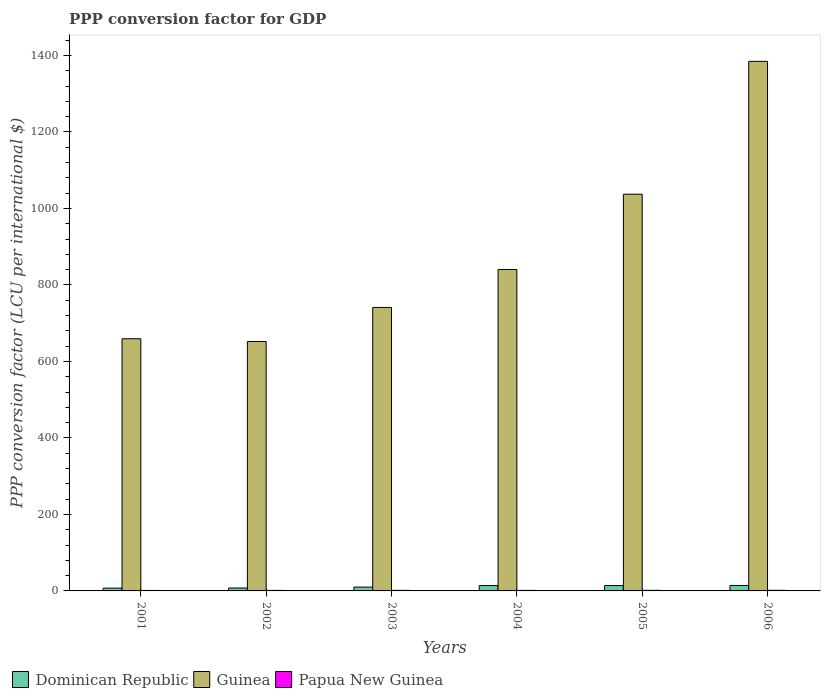How many different coloured bars are there?
Provide a succinct answer. 3. How many groups of bars are there?
Provide a succinct answer. 6. Are the number of bars per tick equal to the number of legend labels?
Your response must be concise. Yes. Are the number of bars on each tick of the X-axis equal?
Provide a short and direct response. Yes. How many bars are there on the 6th tick from the left?
Make the answer very short. 3. How many bars are there on the 5th tick from the right?
Your answer should be compact. 3. In how many cases, is the number of bars for a given year not equal to the number of legend labels?
Ensure brevity in your answer.  0. What is the PPP conversion factor for GDP in Papua New Guinea in 2001?
Provide a succinct answer. 1.29. Across all years, what is the maximum PPP conversion factor for GDP in Papua New Guinea?
Offer a terse response. 1.62. Across all years, what is the minimum PPP conversion factor for GDP in Papua New Guinea?
Offer a terse response. 1.29. What is the total PPP conversion factor for GDP in Guinea in the graph?
Offer a very short reply. 5315.08. What is the difference between the PPP conversion factor for GDP in Papua New Guinea in 2001 and that in 2003?
Your response must be concise. -0.19. What is the difference between the PPP conversion factor for GDP in Guinea in 2005 and the PPP conversion factor for GDP in Papua New Guinea in 2004?
Keep it short and to the point. 1035.92. What is the average PPP conversion factor for GDP in Papua New Guinea per year?
Ensure brevity in your answer.  1.46. In the year 2003, what is the difference between the PPP conversion factor for GDP in Guinea and PPP conversion factor for GDP in Papua New Guinea?
Offer a terse response. 739.67. In how many years, is the PPP conversion factor for GDP in Dominican Republic greater than 400 LCU?
Your response must be concise. 0. What is the ratio of the PPP conversion factor for GDP in Dominican Republic in 2002 to that in 2003?
Your answer should be very brief. 0.76. Is the PPP conversion factor for GDP in Papua New Guinea in 2003 less than that in 2006?
Provide a succinct answer. Yes. Is the difference between the PPP conversion factor for GDP in Guinea in 2002 and 2006 greater than the difference between the PPP conversion factor for GDP in Papua New Guinea in 2002 and 2006?
Offer a terse response. No. What is the difference between the highest and the second highest PPP conversion factor for GDP in Guinea?
Offer a very short reply. 347.33. What is the difference between the highest and the lowest PPP conversion factor for GDP in Papua New Guinea?
Make the answer very short. 0.33. In how many years, is the PPP conversion factor for GDP in Papua New Guinea greater than the average PPP conversion factor for GDP in Papua New Guinea taken over all years?
Keep it short and to the point. 3. What does the 3rd bar from the left in 2004 represents?
Your answer should be compact. Papua New Guinea. What does the 1st bar from the right in 2005 represents?
Provide a short and direct response. Papua New Guinea. How many bars are there?
Your answer should be very brief. 18. Are all the bars in the graph horizontal?
Provide a short and direct response. No. How many years are there in the graph?
Your answer should be very brief. 6. What is the difference between two consecutive major ticks on the Y-axis?
Your answer should be very brief. 200. Are the values on the major ticks of Y-axis written in scientific E-notation?
Offer a very short reply. No. Does the graph contain any zero values?
Make the answer very short. No. Does the graph contain grids?
Offer a very short reply. No. Where does the legend appear in the graph?
Keep it short and to the point. Bottom left. How many legend labels are there?
Ensure brevity in your answer.  3. How are the legend labels stacked?
Give a very brief answer. Horizontal. What is the title of the graph?
Keep it short and to the point. PPP conversion factor for GDP. Does "United Arab Emirates" appear as one of the legend labels in the graph?
Provide a succinct answer. No. What is the label or title of the X-axis?
Your answer should be very brief. Years. What is the label or title of the Y-axis?
Provide a succinct answer. PPP conversion factor (LCU per international $). What is the PPP conversion factor (LCU per international $) of Dominican Republic in 2001?
Give a very brief answer. 7.31. What is the PPP conversion factor (LCU per international $) of Guinea in 2001?
Keep it short and to the point. 659.32. What is the PPP conversion factor (LCU per international $) in Papua New Guinea in 2001?
Offer a very short reply. 1.29. What is the PPP conversion factor (LCU per international $) of Dominican Republic in 2002?
Your answer should be compact. 7.59. What is the PPP conversion factor (LCU per international $) in Guinea in 2002?
Ensure brevity in your answer.  652.16. What is the PPP conversion factor (LCU per international $) of Papua New Guinea in 2002?
Your response must be concise. 1.42. What is the PPP conversion factor (LCU per international $) in Dominican Republic in 2003?
Provide a short and direct response. 9.94. What is the PPP conversion factor (LCU per international $) in Guinea in 2003?
Give a very brief answer. 741.15. What is the PPP conversion factor (LCU per international $) in Papua New Guinea in 2003?
Give a very brief answer. 1.47. What is the PPP conversion factor (LCU per international $) of Dominican Republic in 2004?
Give a very brief answer. 14.05. What is the PPP conversion factor (LCU per international $) of Guinea in 2004?
Your response must be concise. 840.48. What is the PPP conversion factor (LCU per international $) of Papua New Guinea in 2004?
Offer a terse response. 1.4. What is the PPP conversion factor (LCU per international $) in Dominican Republic in 2005?
Your answer should be compact. 13.98. What is the PPP conversion factor (LCU per international $) of Guinea in 2005?
Offer a terse response. 1037.32. What is the PPP conversion factor (LCU per international $) in Papua New Guinea in 2005?
Your answer should be compact. 1.53. What is the PPP conversion factor (LCU per international $) of Dominican Republic in 2006?
Your answer should be compact. 14.29. What is the PPP conversion factor (LCU per international $) in Guinea in 2006?
Make the answer very short. 1384.65. What is the PPP conversion factor (LCU per international $) of Papua New Guinea in 2006?
Make the answer very short. 1.62. Across all years, what is the maximum PPP conversion factor (LCU per international $) of Dominican Republic?
Keep it short and to the point. 14.29. Across all years, what is the maximum PPP conversion factor (LCU per international $) in Guinea?
Provide a succinct answer. 1384.65. Across all years, what is the maximum PPP conversion factor (LCU per international $) of Papua New Guinea?
Make the answer very short. 1.62. Across all years, what is the minimum PPP conversion factor (LCU per international $) in Dominican Republic?
Your answer should be very brief. 7.31. Across all years, what is the minimum PPP conversion factor (LCU per international $) of Guinea?
Ensure brevity in your answer.  652.16. Across all years, what is the minimum PPP conversion factor (LCU per international $) of Papua New Guinea?
Offer a very short reply. 1.29. What is the total PPP conversion factor (LCU per international $) in Dominican Republic in the graph?
Your response must be concise. 67.16. What is the total PPP conversion factor (LCU per international $) of Guinea in the graph?
Your answer should be compact. 5315.08. What is the total PPP conversion factor (LCU per international $) in Papua New Guinea in the graph?
Offer a very short reply. 8.73. What is the difference between the PPP conversion factor (LCU per international $) in Dominican Republic in 2001 and that in 2002?
Provide a succinct answer. -0.28. What is the difference between the PPP conversion factor (LCU per international $) of Guinea in 2001 and that in 2002?
Offer a very short reply. 7.16. What is the difference between the PPP conversion factor (LCU per international $) in Papua New Guinea in 2001 and that in 2002?
Offer a very short reply. -0.14. What is the difference between the PPP conversion factor (LCU per international $) in Dominican Republic in 2001 and that in 2003?
Provide a succinct answer. -2.64. What is the difference between the PPP conversion factor (LCU per international $) of Guinea in 2001 and that in 2003?
Ensure brevity in your answer.  -81.83. What is the difference between the PPP conversion factor (LCU per international $) in Papua New Guinea in 2001 and that in 2003?
Ensure brevity in your answer.  -0.19. What is the difference between the PPP conversion factor (LCU per international $) in Dominican Republic in 2001 and that in 2004?
Give a very brief answer. -6.74. What is the difference between the PPP conversion factor (LCU per international $) in Guinea in 2001 and that in 2004?
Keep it short and to the point. -181.16. What is the difference between the PPP conversion factor (LCU per international $) in Papua New Guinea in 2001 and that in 2004?
Make the answer very short. -0.12. What is the difference between the PPP conversion factor (LCU per international $) of Dominican Republic in 2001 and that in 2005?
Ensure brevity in your answer.  -6.67. What is the difference between the PPP conversion factor (LCU per international $) in Guinea in 2001 and that in 2005?
Your response must be concise. -378. What is the difference between the PPP conversion factor (LCU per international $) of Papua New Guinea in 2001 and that in 2005?
Your answer should be compact. -0.24. What is the difference between the PPP conversion factor (LCU per international $) in Dominican Republic in 2001 and that in 2006?
Your answer should be very brief. -6.99. What is the difference between the PPP conversion factor (LCU per international $) in Guinea in 2001 and that in 2006?
Give a very brief answer. -725.33. What is the difference between the PPP conversion factor (LCU per international $) of Papua New Guinea in 2001 and that in 2006?
Make the answer very short. -0.33. What is the difference between the PPP conversion factor (LCU per international $) in Dominican Republic in 2002 and that in 2003?
Offer a terse response. -2.35. What is the difference between the PPP conversion factor (LCU per international $) of Guinea in 2002 and that in 2003?
Keep it short and to the point. -88.98. What is the difference between the PPP conversion factor (LCU per international $) of Papua New Guinea in 2002 and that in 2003?
Your answer should be very brief. -0.05. What is the difference between the PPP conversion factor (LCU per international $) in Dominican Republic in 2002 and that in 2004?
Keep it short and to the point. -6.46. What is the difference between the PPP conversion factor (LCU per international $) of Guinea in 2002 and that in 2004?
Your answer should be compact. -188.32. What is the difference between the PPP conversion factor (LCU per international $) in Papua New Guinea in 2002 and that in 2004?
Offer a terse response. 0.02. What is the difference between the PPP conversion factor (LCU per international $) in Dominican Republic in 2002 and that in 2005?
Offer a very short reply. -6.39. What is the difference between the PPP conversion factor (LCU per international $) in Guinea in 2002 and that in 2005?
Keep it short and to the point. -385.16. What is the difference between the PPP conversion factor (LCU per international $) of Papua New Guinea in 2002 and that in 2005?
Your answer should be compact. -0.1. What is the difference between the PPP conversion factor (LCU per international $) in Dominican Republic in 2002 and that in 2006?
Keep it short and to the point. -6.71. What is the difference between the PPP conversion factor (LCU per international $) in Guinea in 2002 and that in 2006?
Your response must be concise. -732.49. What is the difference between the PPP conversion factor (LCU per international $) of Papua New Guinea in 2002 and that in 2006?
Make the answer very short. -0.2. What is the difference between the PPP conversion factor (LCU per international $) of Dominican Republic in 2003 and that in 2004?
Ensure brevity in your answer.  -4.11. What is the difference between the PPP conversion factor (LCU per international $) in Guinea in 2003 and that in 2004?
Give a very brief answer. -99.34. What is the difference between the PPP conversion factor (LCU per international $) of Papua New Guinea in 2003 and that in 2004?
Offer a very short reply. 0.07. What is the difference between the PPP conversion factor (LCU per international $) in Dominican Republic in 2003 and that in 2005?
Offer a terse response. -4.04. What is the difference between the PPP conversion factor (LCU per international $) in Guinea in 2003 and that in 2005?
Keep it short and to the point. -296.18. What is the difference between the PPP conversion factor (LCU per international $) in Papua New Guinea in 2003 and that in 2005?
Make the answer very short. -0.05. What is the difference between the PPP conversion factor (LCU per international $) in Dominican Republic in 2003 and that in 2006?
Offer a terse response. -4.35. What is the difference between the PPP conversion factor (LCU per international $) of Guinea in 2003 and that in 2006?
Offer a terse response. -643.5. What is the difference between the PPP conversion factor (LCU per international $) of Papua New Guinea in 2003 and that in 2006?
Your answer should be compact. -0.15. What is the difference between the PPP conversion factor (LCU per international $) of Dominican Republic in 2004 and that in 2005?
Make the answer very short. 0.07. What is the difference between the PPP conversion factor (LCU per international $) of Guinea in 2004 and that in 2005?
Your answer should be very brief. -196.84. What is the difference between the PPP conversion factor (LCU per international $) of Papua New Guinea in 2004 and that in 2005?
Your response must be concise. -0.12. What is the difference between the PPP conversion factor (LCU per international $) of Dominican Republic in 2004 and that in 2006?
Your answer should be very brief. -0.24. What is the difference between the PPP conversion factor (LCU per international $) in Guinea in 2004 and that in 2006?
Offer a very short reply. -544.16. What is the difference between the PPP conversion factor (LCU per international $) in Papua New Guinea in 2004 and that in 2006?
Your answer should be compact. -0.22. What is the difference between the PPP conversion factor (LCU per international $) of Dominican Republic in 2005 and that in 2006?
Your response must be concise. -0.32. What is the difference between the PPP conversion factor (LCU per international $) in Guinea in 2005 and that in 2006?
Give a very brief answer. -347.33. What is the difference between the PPP conversion factor (LCU per international $) in Papua New Guinea in 2005 and that in 2006?
Your answer should be very brief. -0.09. What is the difference between the PPP conversion factor (LCU per international $) of Dominican Republic in 2001 and the PPP conversion factor (LCU per international $) of Guinea in 2002?
Offer a terse response. -644.86. What is the difference between the PPP conversion factor (LCU per international $) in Dominican Republic in 2001 and the PPP conversion factor (LCU per international $) in Papua New Guinea in 2002?
Your answer should be very brief. 5.88. What is the difference between the PPP conversion factor (LCU per international $) in Guinea in 2001 and the PPP conversion factor (LCU per international $) in Papua New Guinea in 2002?
Ensure brevity in your answer.  657.9. What is the difference between the PPP conversion factor (LCU per international $) in Dominican Republic in 2001 and the PPP conversion factor (LCU per international $) in Guinea in 2003?
Provide a short and direct response. -733.84. What is the difference between the PPP conversion factor (LCU per international $) of Dominican Republic in 2001 and the PPP conversion factor (LCU per international $) of Papua New Guinea in 2003?
Offer a very short reply. 5.83. What is the difference between the PPP conversion factor (LCU per international $) in Guinea in 2001 and the PPP conversion factor (LCU per international $) in Papua New Guinea in 2003?
Your answer should be compact. 657.85. What is the difference between the PPP conversion factor (LCU per international $) of Dominican Republic in 2001 and the PPP conversion factor (LCU per international $) of Guinea in 2004?
Your answer should be compact. -833.18. What is the difference between the PPP conversion factor (LCU per international $) of Dominican Republic in 2001 and the PPP conversion factor (LCU per international $) of Papua New Guinea in 2004?
Your answer should be very brief. 5.9. What is the difference between the PPP conversion factor (LCU per international $) in Guinea in 2001 and the PPP conversion factor (LCU per international $) in Papua New Guinea in 2004?
Provide a short and direct response. 657.92. What is the difference between the PPP conversion factor (LCU per international $) of Dominican Republic in 2001 and the PPP conversion factor (LCU per international $) of Guinea in 2005?
Provide a short and direct response. -1030.02. What is the difference between the PPP conversion factor (LCU per international $) of Dominican Republic in 2001 and the PPP conversion factor (LCU per international $) of Papua New Guinea in 2005?
Make the answer very short. 5.78. What is the difference between the PPP conversion factor (LCU per international $) in Guinea in 2001 and the PPP conversion factor (LCU per international $) in Papua New Guinea in 2005?
Your response must be concise. 657.79. What is the difference between the PPP conversion factor (LCU per international $) in Dominican Republic in 2001 and the PPP conversion factor (LCU per international $) in Guinea in 2006?
Give a very brief answer. -1377.34. What is the difference between the PPP conversion factor (LCU per international $) in Dominican Republic in 2001 and the PPP conversion factor (LCU per international $) in Papua New Guinea in 2006?
Provide a short and direct response. 5.68. What is the difference between the PPP conversion factor (LCU per international $) of Guinea in 2001 and the PPP conversion factor (LCU per international $) of Papua New Guinea in 2006?
Your response must be concise. 657.7. What is the difference between the PPP conversion factor (LCU per international $) of Dominican Republic in 2002 and the PPP conversion factor (LCU per international $) of Guinea in 2003?
Offer a terse response. -733.56. What is the difference between the PPP conversion factor (LCU per international $) in Dominican Republic in 2002 and the PPP conversion factor (LCU per international $) in Papua New Guinea in 2003?
Make the answer very short. 6.12. What is the difference between the PPP conversion factor (LCU per international $) in Guinea in 2002 and the PPP conversion factor (LCU per international $) in Papua New Guinea in 2003?
Offer a terse response. 650.69. What is the difference between the PPP conversion factor (LCU per international $) in Dominican Republic in 2002 and the PPP conversion factor (LCU per international $) in Guinea in 2004?
Your answer should be very brief. -832.9. What is the difference between the PPP conversion factor (LCU per international $) of Dominican Republic in 2002 and the PPP conversion factor (LCU per international $) of Papua New Guinea in 2004?
Give a very brief answer. 6.18. What is the difference between the PPP conversion factor (LCU per international $) of Guinea in 2002 and the PPP conversion factor (LCU per international $) of Papua New Guinea in 2004?
Ensure brevity in your answer.  650.76. What is the difference between the PPP conversion factor (LCU per international $) in Dominican Republic in 2002 and the PPP conversion factor (LCU per international $) in Guinea in 2005?
Your answer should be compact. -1029.73. What is the difference between the PPP conversion factor (LCU per international $) in Dominican Republic in 2002 and the PPP conversion factor (LCU per international $) in Papua New Guinea in 2005?
Provide a short and direct response. 6.06. What is the difference between the PPP conversion factor (LCU per international $) of Guinea in 2002 and the PPP conversion factor (LCU per international $) of Papua New Guinea in 2005?
Your answer should be compact. 650.64. What is the difference between the PPP conversion factor (LCU per international $) of Dominican Republic in 2002 and the PPP conversion factor (LCU per international $) of Guinea in 2006?
Offer a terse response. -1377.06. What is the difference between the PPP conversion factor (LCU per international $) of Dominican Republic in 2002 and the PPP conversion factor (LCU per international $) of Papua New Guinea in 2006?
Your answer should be very brief. 5.97. What is the difference between the PPP conversion factor (LCU per international $) of Guinea in 2002 and the PPP conversion factor (LCU per international $) of Papua New Guinea in 2006?
Keep it short and to the point. 650.54. What is the difference between the PPP conversion factor (LCU per international $) in Dominican Republic in 2003 and the PPP conversion factor (LCU per international $) in Guinea in 2004?
Give a very brief answer. -830.54. What is the difference between the PPP conversion factor (LCU per international $) in Dominican Republic in 2003 and the PPP conversion factor (LCU per international $) in Papua New Guinea in 2004?
Your response must be concise. 8.54. What is the difference between the PPP conversion factor (LCU per international $) in Guinea in 2003 and the PPP conversion factor (LCU per international $) in Papua New Guinea in 2004?
Your answer should be compact. 739.74. What is the difference between the PPP conversion factor (LCU per international $) of Dominican Republic in 2003 and the PPP conversion factor (LCU per international $) of Guinea in 2005?
Offer a very short reply. -1027.38. What is the difference between the PPP conversion factor (LCU per international $) of Dominican Republic in 2003 and the PPP conversion factor (LCU per international $) of Papua New Guinea in 2005?
Keep it short and to the point. 8.42. What is the difference between the PPP conversion factor (LCU per international $) of Guinea in 2003 and the PPP conversion factor (LCU per international $) of Papua New Guinea in 2005?
Give a very brief answer. 739.62. What is the difference between the PPP conversion factor (LCU per international $) in Dominican Republic in 2003 and the PPP conversion factor (LCU per international $) in Guinea in 2006?
Provide a short and direct response. -1374.71. What is the difference between the PPP conversion factor (LCU per international $) of Dominican Republic in 2003 and the PPP conversion factor (LCU per international $) of Papua New Guinea in 2006?
Offer a very short reply. 8.32. What is the difference between the PPP conversion factor (LCU per international $) of Guinea in 2003 and the PPP conversion factor (LCU per international $) of Papua New Guinea in 2006?
Provide a succinct answer. 739.53. What is the difference between the PPP conversion factor (LCU per international $) of Dominican Republic in 2004 and the PPP conversion factor (LCU per international $) of Guinea in 2005?
Provide a short and direct response. -1023.27. What is the difference between the PPP conversion factor (LCU per international $) in Dominican Republic in 2004 and the PPP conversion factor (LCU per international $) in Papua New Guinea in 2005?
Your answer should be very brief. 12.52. What is the difference between the PPP conversion factor (LCU per international $) of Guinea in 2004 and the PPP conversion factor (LCU per international $) of Papua New Guinea in 2005?
Your response must be concise. 838.96. What is the difference between the PPP conversion factor (LCU per international $) of Dominican Republic in 2004 and the PPP conversion factor (LCU per international $) of Guinea in 2006?
Keep it short and to the point. -1370.6. What is the difference between the PPP conversion factor (LCU per international $) of Dominican Republic in 2004 and the PPP conversion factor (LCU per international $) of Papua New Guinea in 2006?
Give a very brief answer. 12.43. What is the difference between the PPP conversion factor (LCU per international $) of Guinea in 2004 and the PPP conversion factor (LCU per international $) of Papua New Guinea in 2006?
Keep it short and to the point. 838.86. What is the difference between the PPP conversion factor (LCU per international $) of Dominican Republic in 2005 and the PPP conversion factor (LCU per international $) of Guinea in 2006?
Offer a very short reply. -1370.67. What is the difference between the PPP conversion factor (LCU per international $) in Dominican Republic in 2005 and the PPP conversion factor (LCU per international $) in Papua New Guinea in 2006?
Provide a short and direct response. 12.36. What is the difference between the PPP conversion factor (LCU per international $) in Guinea in 2005 and the PPP conversion factor (LCU per international $) in Papua New Guinea in 2006?
Your answer should be compact. 1035.7. What is the average PPP conversion factor (LCU per international $) of Dominican Republic per year?
Your response must be concise. 11.19. What is the average PPP conversion factor (LCU per international $) of Guinea per year?
Offer a terse response. 885.85. What is the average PPP conversion factor (LCU per international $) in Papua New Guinea per year?
Provide a short and direct response. 1.46. In the year 2001, what is the difference between the PPP conversion factor (LCU per international $) of Dominican Republic and PPP conversion factor (LCU per international $) of Guinea?
Ensure brevity in your answer.  -652.01. In the year 2001, what is the difference between the PPP conversion factor (LCU per international $) in Dominican Republic and PPP conversion factor (LCU per international $) in Papua New Guinea?
Make the answer very short. 6.02. In the year 2001, what is the difference between the PPP conversion factor (LCU per international $) of Guinea and PPP conversion factor (LCU per international $) of Papua New Guinea?
Your answer should be very brief. 658.03. In the year 2002, what is the difference between the PPP conversion factor (LCU per international $) in Dominican Republic and PPP conversion factor (LCU per international $) in Guinea?
Offer a terse response. -644.57. In the year 2002, what is the difference between the PPP conversion factor (LCU per international $) of Dominican Republic and PPP conversion factor (LCU per international $) of Papua New Guinea?
Ensure brevity in your answer.  6.17. In the year 2002, what is the difference between the PPP conversion factor (LCU per international $) of Guinea and PPP conversion factor (LCU per international $) of Papua New Guinea?
Ensure brevity in your answer.  650.74. In the year 2003, what is the difference between the PPP conversion factor (LCU per international $) in Dominican Republic and PPP conversion factor (LCU per international $) in Guinea?
Offer a terse response. -731.2. In the year 2003, what is the difference between the PPP conversion factor (LCU per international $) in Dominican Republic and PPP conversion factor (LCU per international $) in Papua New Guinea?
Your response must be concise. 8.47. In the year 2003, what is the difference between the PPP conversion factor (LCU per international $) in Guinea and PPP conversion factor (LCU per international $) in Papua New Guinea?
Make the answer very short. 739.67. In the year 2004, what is the difference between the PPP conversion factor (LCU per international $) in Dominican Republic and PPP conversion factor (LCU per international $) in Guinea?
Your response must be concise. -826.43. In the year 2004, what is the difference between the PPP conversion factor (LCU per international $) of Dominican Republic and PPP conversion factor (LCU per international $) of Papua New Guinea?
Keep it short and to the point. 12.64. In the year 2004, what is the difference between the PPP conversion factor (LCU per international $) in Guinea and PPP conversion factor (LCU per international $) in Papua New Guinea?
Offer a terse response. 839.08. In the year 2005, what is the difference between the PPP conversion factor (LCU per international $) of Dominican Republic and PPP conversion factor (LCU per international $) of Guinea?
Give a very brief answer. -1023.34. In the year 2005, what is the difference between the PPP conversion factor (LCU per international $) of Dominican Republic and PPP conversion factor (LCU per international $) of Papua New Guinea?
Keep it short and to the point. 12.45. In the year 2005, what is the difference between the PPP conversion factor (LCU per international $) of Guinea and PPP conversion factor (LCU per international $) of Papua New Guinea?
Provide a succinct answer. 1035.8. In the year 2006, what is the difference between the PPP conversion factor (LCU per international $) in Dominican Republic and PPP conversion factor (LCU per international $) in Guinea?
Provide a short and direct response. -1370.35. In the year 2006, what is the difference between the PPP conversion factor (LCU per international $) in Dominican Republic and PPP conversion factor (LCU per international $) in Papua New Guinea?
Offer a terse response. 12.67. In the year 2006, what is the difference between the PPP conversion factor (LCU per international $) in Guinea and PPP conversion factor (LCU per international $) in Papua New Guinea?
Your response must be concise. 1383.03. What is the ratio of the PPP conversion factor (LCU per international $) in Dominican Republic in 2001 to that in 2002?
Ensure brevity in your answer.  0.96. What is the ratio of the PPP conversion factor (LCU per international $) of Papua New Guinea in 2001 to that in 2002?
Provide a succinct answer. 0.9. What is the ratio of the PPP conversion factor (LCU per international $) of Dominican Republic in 2001 to that in 2003?
Offer a very short reply. 0.73. What is the ratio of the PPP conversion factor (LCU per international $) of Guinea in 2001 to that in 2003?
Provide a succinct answer. 0.89. What is the ratio of the PPP conversion factor (LCU per international $) of Papua New Guinea in 2001 to that in 2003?
Your answer should be compact. 0.87. What is the ratio of the PPP conversion factor (LCU per international $) of Dominican Republic in 2001 to that in 2004?
Your response must be concise. 0.52. What is the ratio of the PPP conversion factor (LCU per international $) in Guinea in 2001 to that in 2004?
Keep it short and to the point. 0.78. What is the ratio of the PPP conversion factor (LCU per international $) of Papua New Guinea in 2001 to that in 2004?
Keep it short and to the point. 0.92. What is the ratio of the PPP conversion factor (LCU per international $) in Dominican Republic in 2001 to that in 2005?
Make the answer very short. 0.52. What is the ratio of the PPP conversion factor (LCU per international $) of Guinea in 2001 to that in 2005?
Keep it short and to the point. 0.64. What is the ratio of the PPP conversion factor (LCU per international $) of Papua New Guinea in 2001 to that in 2005?
Keep it short and to the point. 0.84. What is the ratio of the PPP conversion factor (LCU per international $) of Dominican Republic in 2001 to that in 2006?
Ensure brevity in your answer.  0.51. What is the ratio of the PPP conversion factor (LCU per international $) of Guinea in 2001 to that in 2006?
Give a very brief answer. 0.48. What is the ratio of the PPP conversion factor (LCU per international $) in Papua New Guinea in 2001 to that in 2006?
Your response must be concise. 0.79. What is the ratio of the PPP conversion factor (LCU per international $) of Dominican Republic in 2002 to that in 2003?
Make the answer very short. 0.76. What is the ratio of the PPP conversion factor (LCU per international $) of Guinea in 2002 to that in 2003?
Provide a short and direct response. 0.88. What is the ratio of the PPP conversion factor (LCU per international $) in Papua New Guinea in 2002 to that in 2003?
Your response must be concise. 0.97. What is the ratio of the PPP conversion factor (LCU per international $) in Dominican Republic in 2002 to that in 2004?
Your answer should be very brief. 0.54. What is the ratio of the PPP conversion factor (LCU per international $) of Guinea in 2002 to that in 2004?
Your answer should be compact. 0.78. What is the ratio of the PPP conversion factor (LCU per international $) in Papua New Guinea in 2002 to that in 2004?
Keep it short and to the point. 1.01. What is the ratio of the PPP conversion factor (LCU per international $) of Dominican Republic in 2002 to that in 2005?
Your answer should be compact. 0.54. What is the ratio of the PPP conversion factor (LCU per international $) in Guinea in 2002 to that in 2005?
Offer a very short reply. 0.63. What is the ratio of the PPP conversion factor (LCU per international $) in Papua New Guinea in 2002 to that in 2005?
Offer a terse response. 0.93. What is the ratio of the PPP conversion factor (LCU per international $) in Dominican Republic in 2002 to that in 2006?
Keep it short and to the point. 0.53. What is the ratio of the PPP conversion factor (LCU per international $) of Guinea in 2002 to that in 2006?
Your response must be concise. 0.47. What is the ratio of the PPP conversion factor (LCU per international $) of Papua New Guinea in 2002 to that in 2006?
Your answer should be very brief. 0.88. What is the ratio of the PPP conversion factor (LCU per international $) of Dominican Republic in 2003 to that in 2004?
Offer a terse response. 0.71. What is the ratio of the PPP conversion factor (LCU per international $) of Guinea in 2003 to that in 2004?
Your answer should be compact. 0.88. What is the ratio of the PPP conversion factor (LCU per international $) in Papua New Guinea in 2003 to that in 2004?
Give a very brief answer. 1.05. What is the ratio of the PPP conversion factor (LCU per international $) in Dominican Republic in 2003 to that in 2005?
Your answer should be very brief. 0.71. What is the ratio of the PPP conversion factor (LCU per international $) in Guinea in 2003 to that in 2005?
Offer a terse response. 0.71. What is the ratio of the PPP conversion factor (LCU per international $) of Papua New Guinea in 2003 to that in 2005?
Give a very brief answer. 0.96. What is the ratio of the PPP conversion factor (LCU per international $) in Dominican Republic in 2003 to that in 2006?
Your response must be concise. 0.7. What is the ratio of the PPP conversion factor (LCU per international $) in Guinea in 2003 to that in 2006?
Make the answer very short. 0.54. What is the ratio of the PPP conversion factor (LCU per international $) of Papua New Guinea in 2003 to that in 2006?
Provide a succinct answer. 0.91. What is the ratio of the PPP conversion factor (LCU per international $) of Dominican Republic in 2004 to that in 2005?
Give a very brief answer. 1.01. What is the ratio of the PPP conversion factor (LCU per international $) of Guinea in 2004 to that in 2005?
Keep it short and to the point. 0.81. What is the ratio of the PPP conversion factor (LCU per international $) of Papua New Guinea in 2004 to that in 2005?
Provide a succinct answer. 0.92. What is the ratio of the PPP conversion factor (LCU per international $) of Dominican Republic in 2004 to that in 2006?
Keep it short and to the point. 0.98. What is the ratio of the PPP conversion factor (LCU per international $) in Guinea in 2004 to that in 2006?
Offer a very short reply. 0.61. What is the ratio of the PPP conversion factor (LCU per international $) of Papua New Guinea in 2004 to that in 2006?
Provide a short and direct response. 0.87. What is the ratio of the PPP conversion factor (LCU per international $) of Dominican Republic in 2005 to that in 2006?
Keep it short and to the point. 0.98. What is the ratio of the PPP conversion factor (LCU per international $) in Guinea in 2005 to that in 2006?
Keep it short and to the point. 0.75. What is the ratio of the PPP conversion factor (LCU per international $) of Papua New Guinea in 2005 to that in 2006?
Offer a very short reply. 0.94. What is the difference between the highest and the second highest PPP conversion factor (LCU per international $) in Dominican Republic?
Your answer should be compact. 0.24. What is the difference between the highest and the second highest PPP conversion factor (LCU per international $) in Guinea?
Your response must be concise. 347.33. What is the difference between the highest and the second highest PPP conversion factor (LCU per international $) in Papua New Guinea?
Provide a short and direct response. 0.09. What is the difference between the highest and the lowest PPP conversion factor (LCU per international $) in Dominican Republic?
Your answer should be very brief. 6.99. What is the difference between the highest and the lowest PPP conversion factor (LCU per international $) in Guinea?
Provide a short and direct response. 732.49. What is the difference between the highest and the lowest PPP conversion factor (LCU per international $) of Papua New Guinea?
Your answer should be compact. 0.33. 